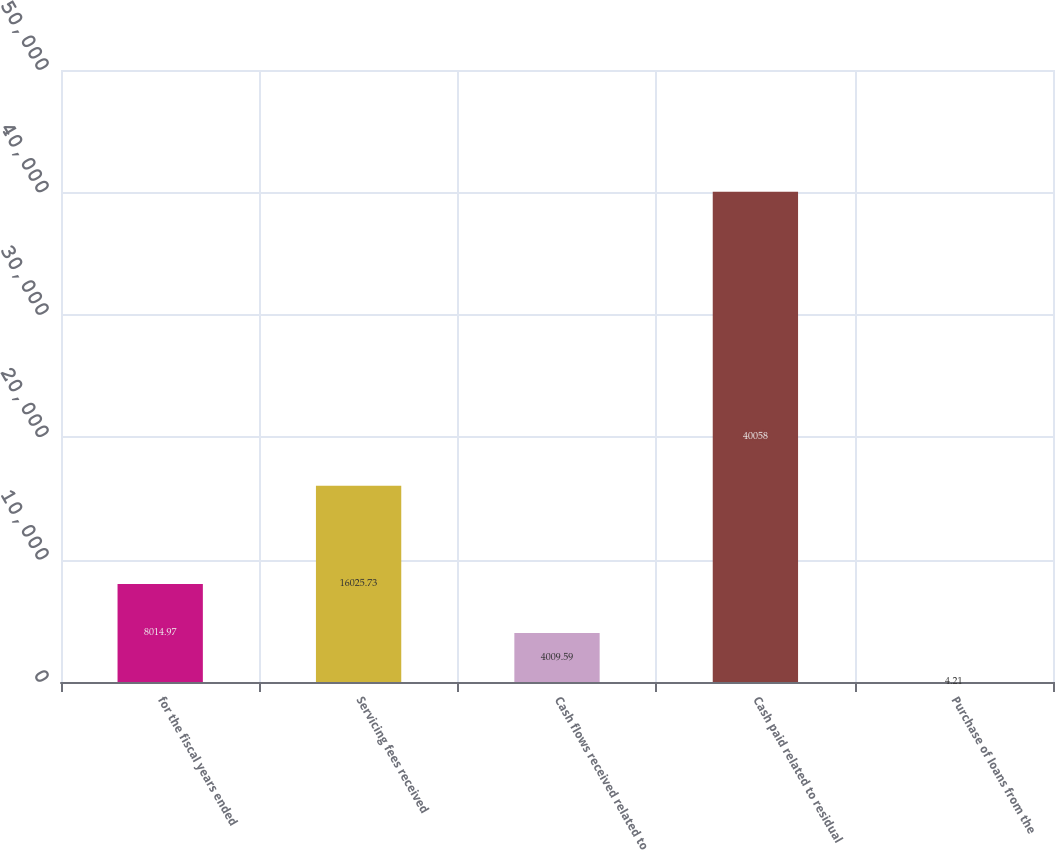Convert chart to OTSL. <chart><loc_0><loc_0><loc_500><loc_500><bar_chart><fcel>for the fiscal years ended<fcel>Servicing fees received<fcel>Cash flows received related to<fcel>Cash paid related to residual<fcel>Purchase of loans from the<nl><fcel>8014.97<fcel>16025.7<fcel>4009.59<fcel>40058<fcel>4.21<nl></chart> 